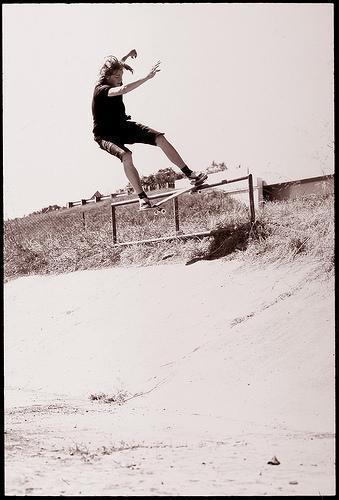How many people are pictured?
Give a very brief answer. 1. How many colors are in this picture?
Give a very brief answer. 2. How many wheels does the skateboard have?
Give a very brief answer. 4. 